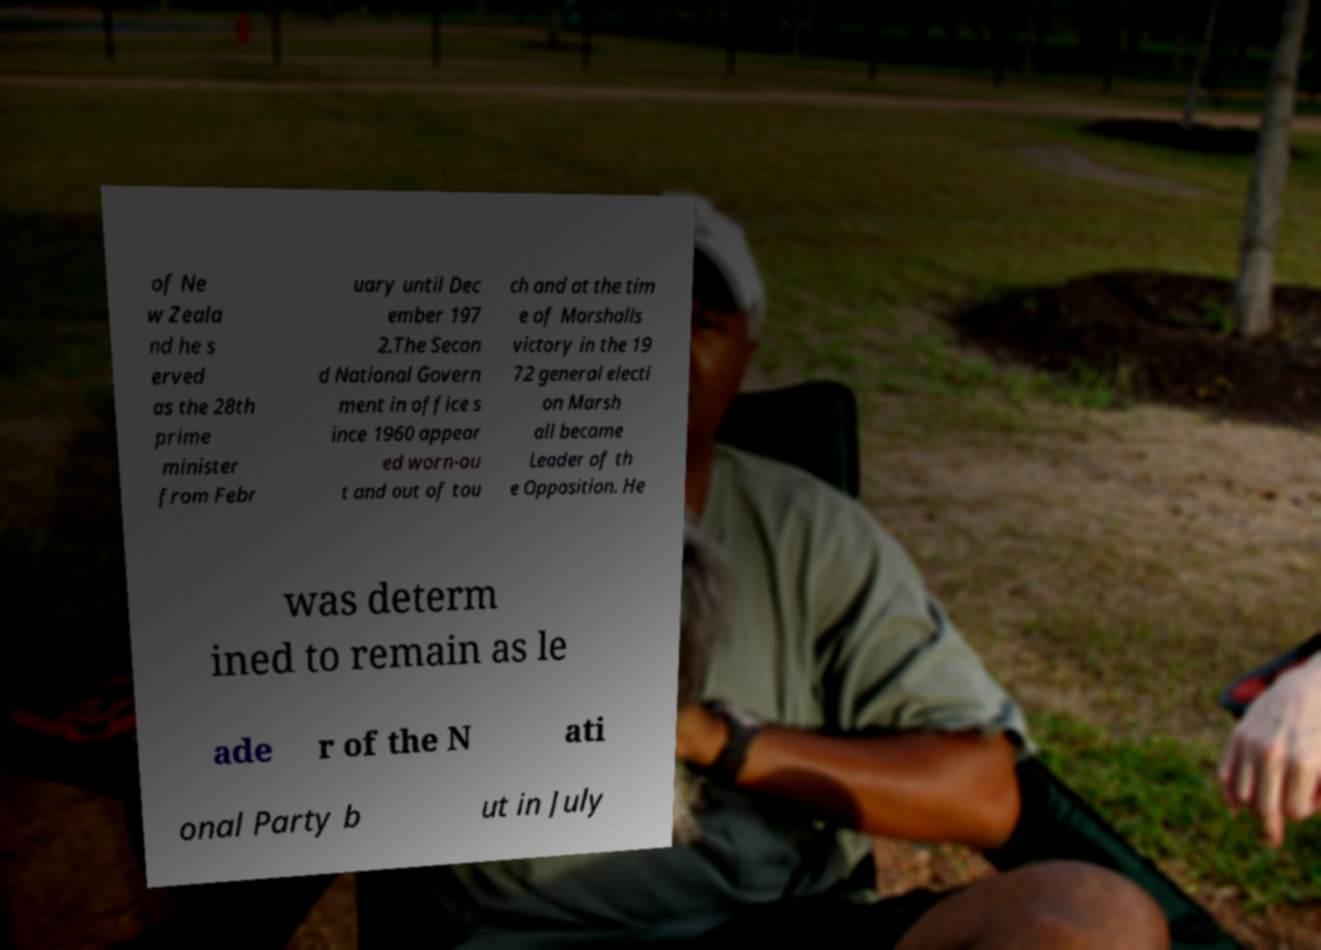I need the written content from this picture converted into text. Can you do that? of Ne w Zeala nd he s erved as the 28th prime minister from Febr uary until Dec ember 197 2.The Secon d National Govern ment in office s ince 1960 appear ed worn-ou t and out of tou ch and at the tim e of Marshalls victory in the 19 72 general electi on Marsh all became Leader of th e Opposition. He was determ ined to remain as le ade r of the N ati onal Party b ut in July 